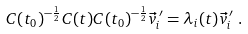<formula> <loc_0><loc_0><loc_500><loc_500>C ( t _ { 0 } ) ^ { - \frac { 1 } { 2 } } C ( t ) C ( t _ { 0 } ) ^ { - \frac { 1 } { 2 } } \vec { v } ^ { \, \prime } _ { i } & = \lambda _ { i } ( t ) \vec { v } ^ { \, \prime } _ { i } \ .</formula> 